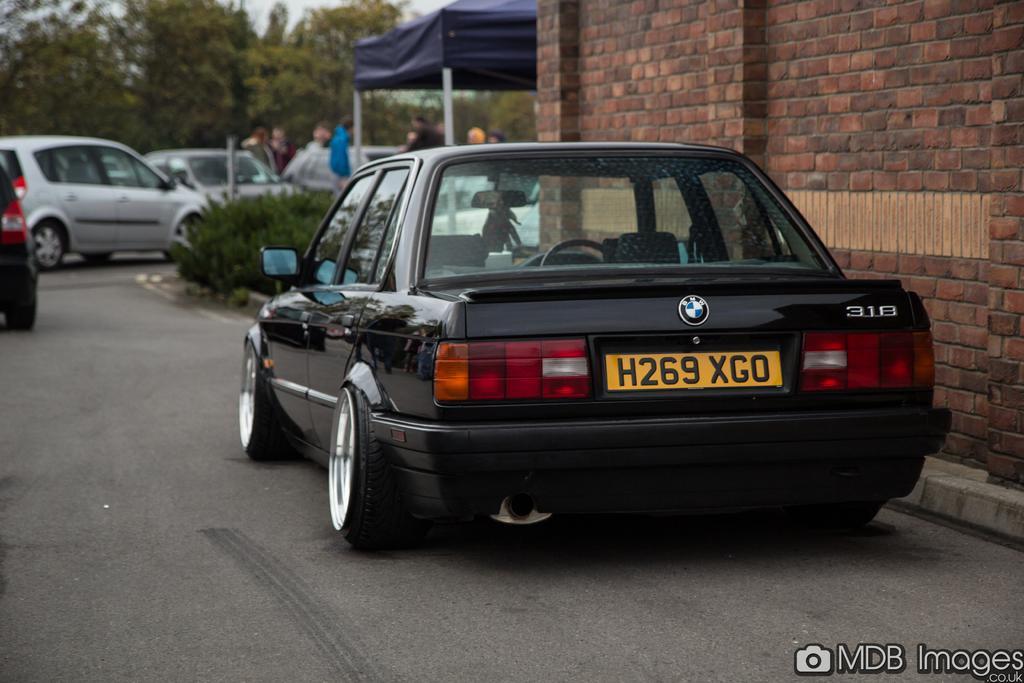Could you give a brief overview of what you see in this image? This is an outside view. Here I can see few cars on the road. Beside the road there are few plants. On the right side there is a wall. In the background there is a tent and trees and also I can see few people standing. In the bottom right-hand corner there is some edited text. 